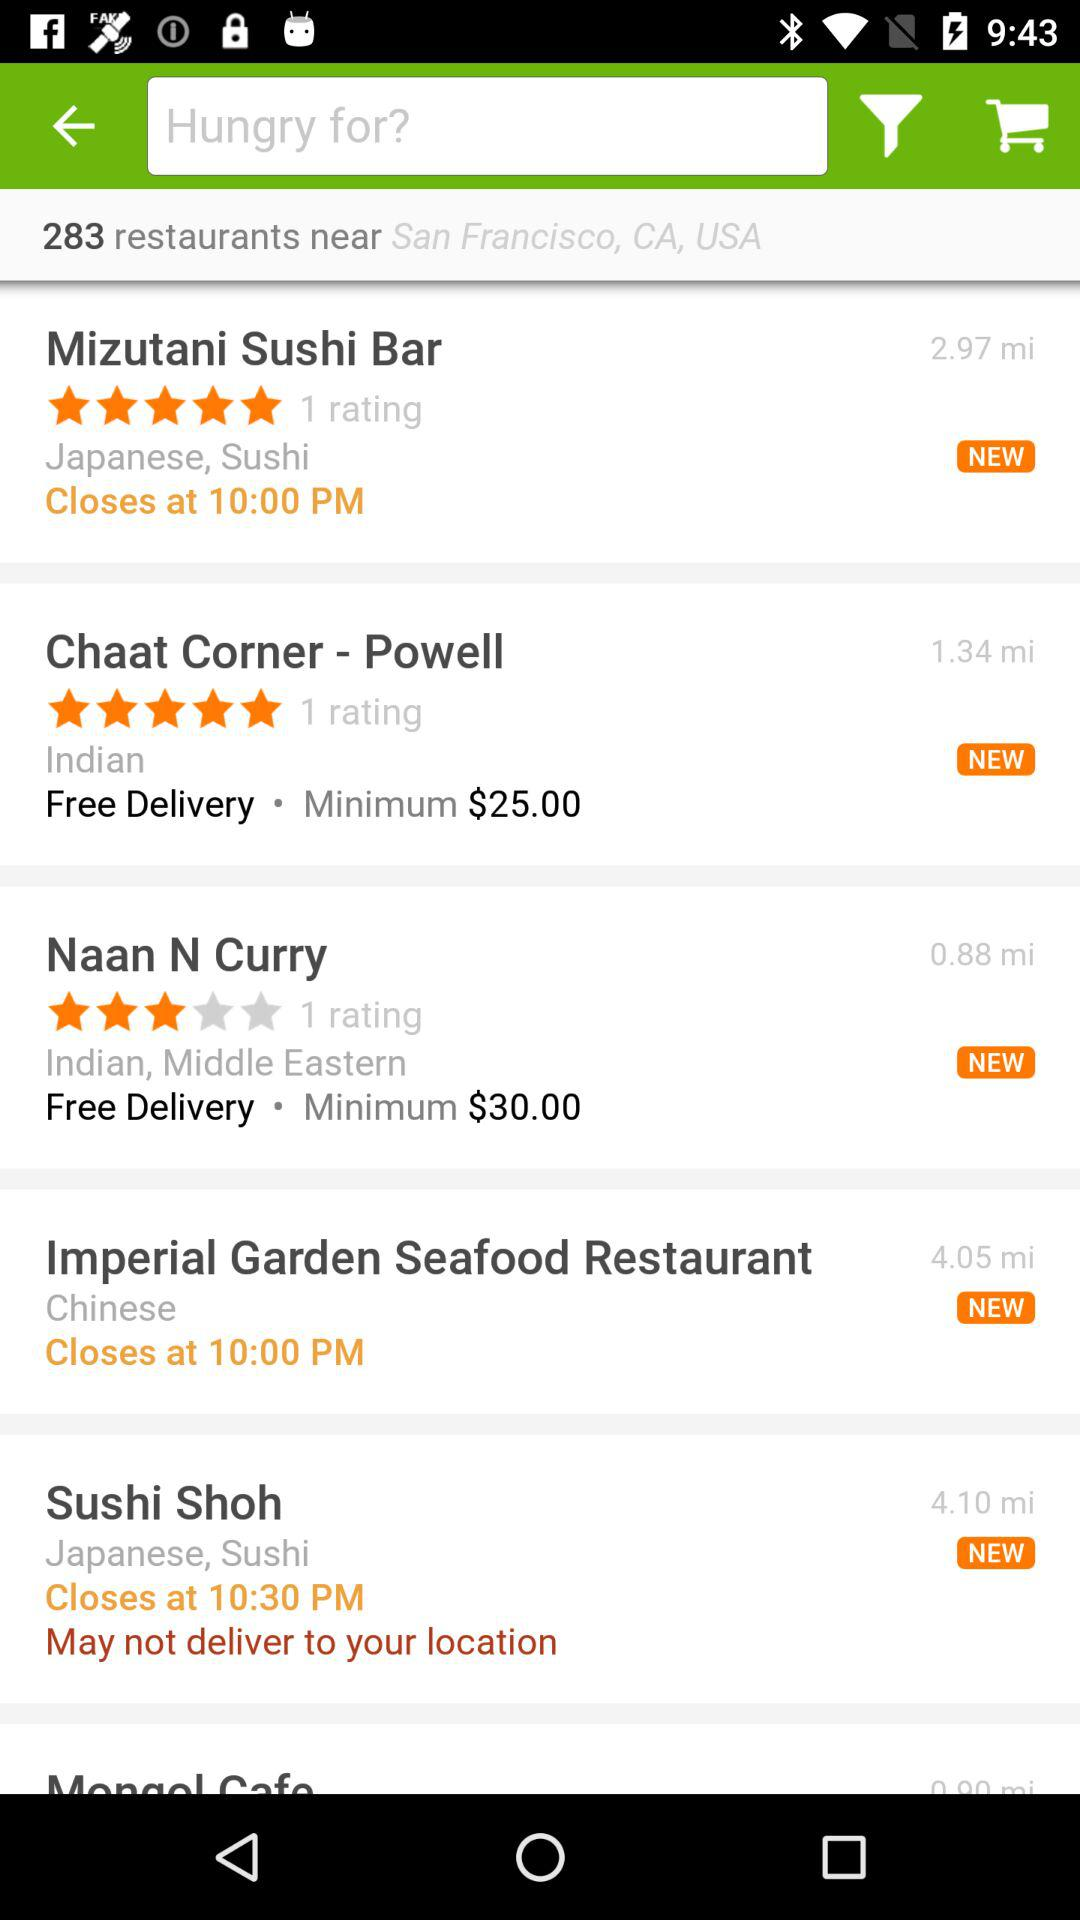What type of food is served at "Imperial Garden Seafood Restaurant"? The type of food is Chinese. 